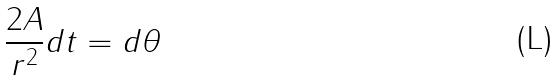Convert formula to latex. <formula><loc_0><loc_0><loc_500><loc_500>\frac { 2 A } { r ^ { 2 } } d t = d \theta</formula> 